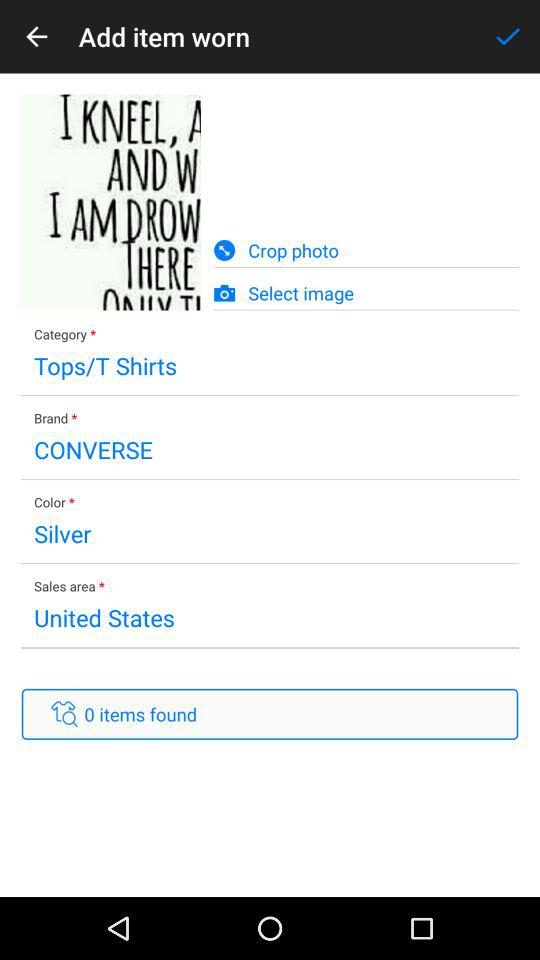What is the category of clothes? The category of clothes is "Tops/T Shirts". 